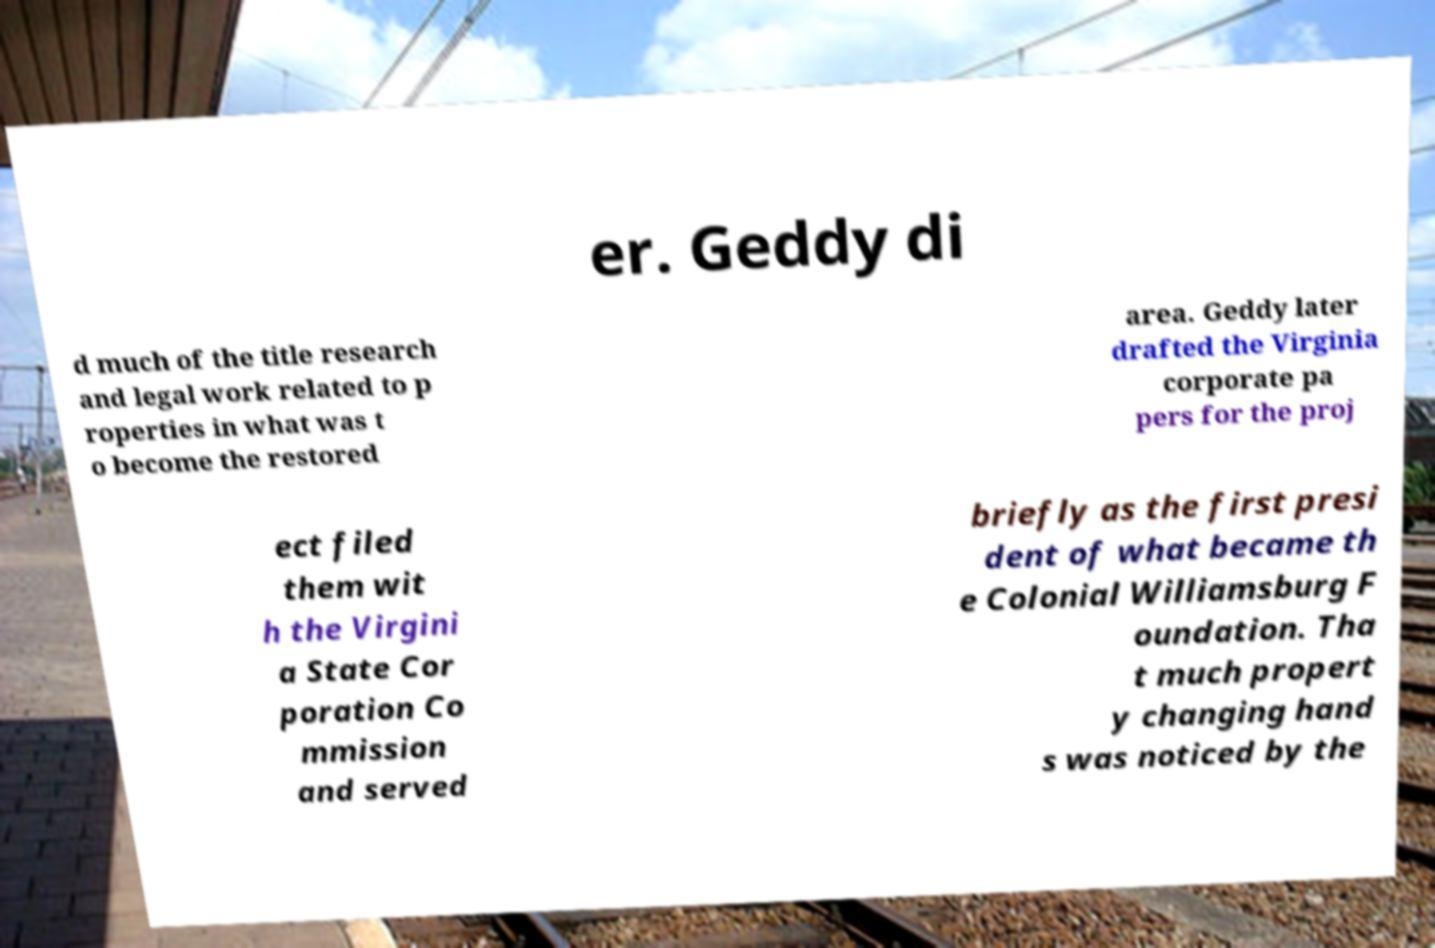Could you extract and type out the text from this image? er. Geddy di d much of the title research and legal work related to p roperties in what was t o become the restored area. Geddy later drafted the Virginia corporate pa pers for the proj ect filed them wit h the Virgini a State Cor poration Co mmission and served briefly as the first presi dent of what became th e Colonial Williamsburg F oundation. Tha t much propert y changing hand s was noticed by the 